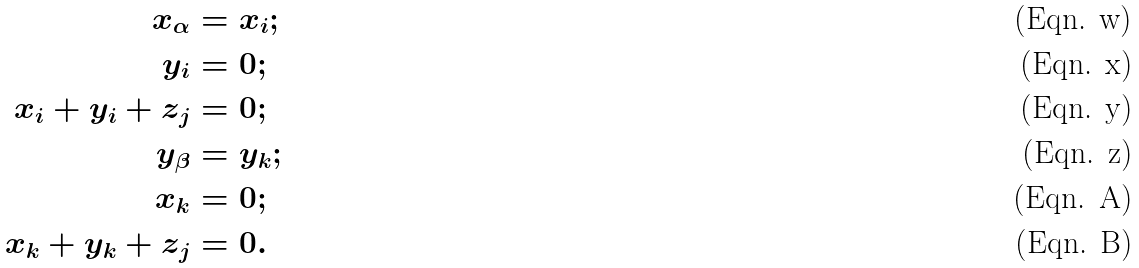Convert formula to latex. <formula><loc_0><loc_0><loc_500><loc_500>x _ { \alpha } & = x _ { i } ; \\ y _ { i } & = 0 ; \\ x _ { i } + y _ { i } + z _ { j } & = 0 ; \\ y _ { \beta } & = y _ { k } ; \\ x _ { k } & = 0 ; \\ x _ { k } + y _ { k } + z _ { j } & = 0 .</formula> 